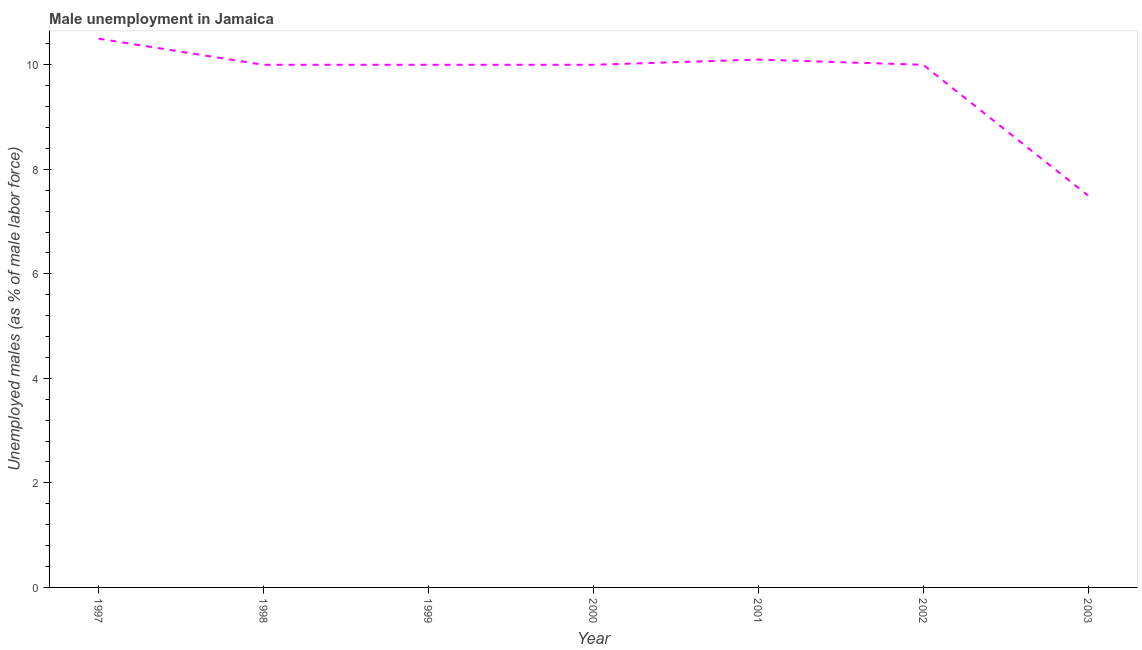Across all years, what is the maximum unemployed males population?
Your answer should be very brief. 10.5. Across all years, what is the minimum unemployed males population?
Make the answer very short. 7.5. In which year was the unemployed males population minimum?
Offer a very short reply. 2003. What is the sum of the unemployed males population?
Ensure brevity in your answer.  68.1. What is the difference between the unemployed males population in 2001 and 2003?
Offer a very short reply. 2.6. What is the average unemployed males population per year?
Provide a succinct answer. 9.73. Do a majority of the years between 1998 and 2000 (inclusive) have unemployed males population greater than 9.6 %?
Provide a succinct answer. Yes. Is the unemployed males population in 2002 less than that in 2003?
Your answer should be compact. No. What is the difference between the highest and the second highest unemployed males population?
Ensure brevity in your answer.  0.4. Is the sum of the unemployed males population in 1999 and 2003 greater than the maximum unemployed males population across all years?
Give a very brief answer. Yes. In how many years, is the unemployed males population greater than the average unemployed males population taken over all years?
Make the answer very short. 6. How many years are there in the graph?
Your answer should be very brief. 7. What is the difference between two consecutive major ticks on the Y-axis?
Provide a succinct answer. 2. What is the title of the graph?
Make the answer very short. Male unemployment in Jamaica. What is the label or title of the Y-axis?
Give a very brief answer. Unemployed males (as % of male labor force). What is the Unemployed males (as % of male labor force) in 1997?
Your answer should be compact. 10.5. What is the Unemployed males (as % of male labor force) in 2000?
Your response must be concise. 10. What is the Unemployed males (as % of male labor force) of 2001?
Keep it short and to the point. 10.1. What is the Unemployed males (as % of male labor force) of 2003?
Ensure brevity in your answer.  7.5. What is the difference between the Unemployed males (as % of male labor force) in 1997 and 1999?
Make the answer very short. 0.5. What is the difference between the Unemployed males (as % of male labor force) in 1997 and 2001?
Make the answer very short. 0.4. What is the difference between the Unemployed males (as % of male labor force) in 1997 and 2002?
Your response must be concise. 0.5. What is the difference between the Unemployed males (as % of male labor force) in 1998 and 1999?
Provide a succinct answer. 0. What is the difference between the Unemployed males (as % of male labor force) in 1998 and 2000?
Give a very brief answer. 0. What is the difference between the Unemployed males (as % of male labor force) in 1998 and 2003?
Your answer should be very brief. 2.5. What is the difference between the Unemployed males (as % of male labor force) in 1999 and 2001?
Your answer should be compact. -0.1. What is the difference between the Unemployed males (as % of male labor force) in 1999 and 2002?
Ensure brevity in your answer.  0. What is the difference between the Unemployed males (as % of male labor force) in 2000 and 2002?
Offer a very short reply. 0. What is the ratio of the Unemployed males (as % of male labor force) in 1997 to that in 1999?
Make the answer very short. 1.05. What is the ratio of the Unemployed males (as % of male labor force) in 1997 to that in 2000?
Your answer should be compact. 1.05. What is the ratio of the Unemployed males (as % of male labor force) in 1997 to that in 2001?
Offer a very short reply. 1.04. What is the ratio of the Unemployed males (as % of male labor force) in 1997 to that in 2003?
Your response must be concise. 1.4. What is the ratio of the Unemployed males (as % of male labor force) in 1998 to that in 1999?
Provide a succinct answer. 1. What is the ratio of the Unemployed males (as % of male labor force) in 1998 to that in 2000?
Give a very brief answer. 1. What is the ratio of the Unemployed males (as % of male labor force) in 1998 to that in 2003?
Give a very brief answer. 1.33. What is the ratio of the Unemployed males (as % of male labor force) in 1999 to that in 2001?
Make the answer very short. 0.99. What is the ratio of the Unemployed males (as % of male labor force) in 1999 to that in 2003?
Your answer should be compact. 1.33. What is the ratio of the Unemployed males (as % of male labor force) in 2000 to that in 2001?
Your answer should be very brief. 0.99. What is the ratio of the Unemployed males (as % of male labor force) in 2000 to that in 2003?
Your response must be concise. 1.33. What is the ratio of the Unemployed males (as % of male labor force) in 2001 to that in 2002?
Make the answer very short. 1.01. What is the ratio of the Unemployed males (as % of male labor force) in 2001 to that in 2003?
Your answer should be very brief. 1.35. What is the ratio of the Unemployed males (as % of male labor force) in 2002 to that in 2003?
Your response must be concise. 1.33. 